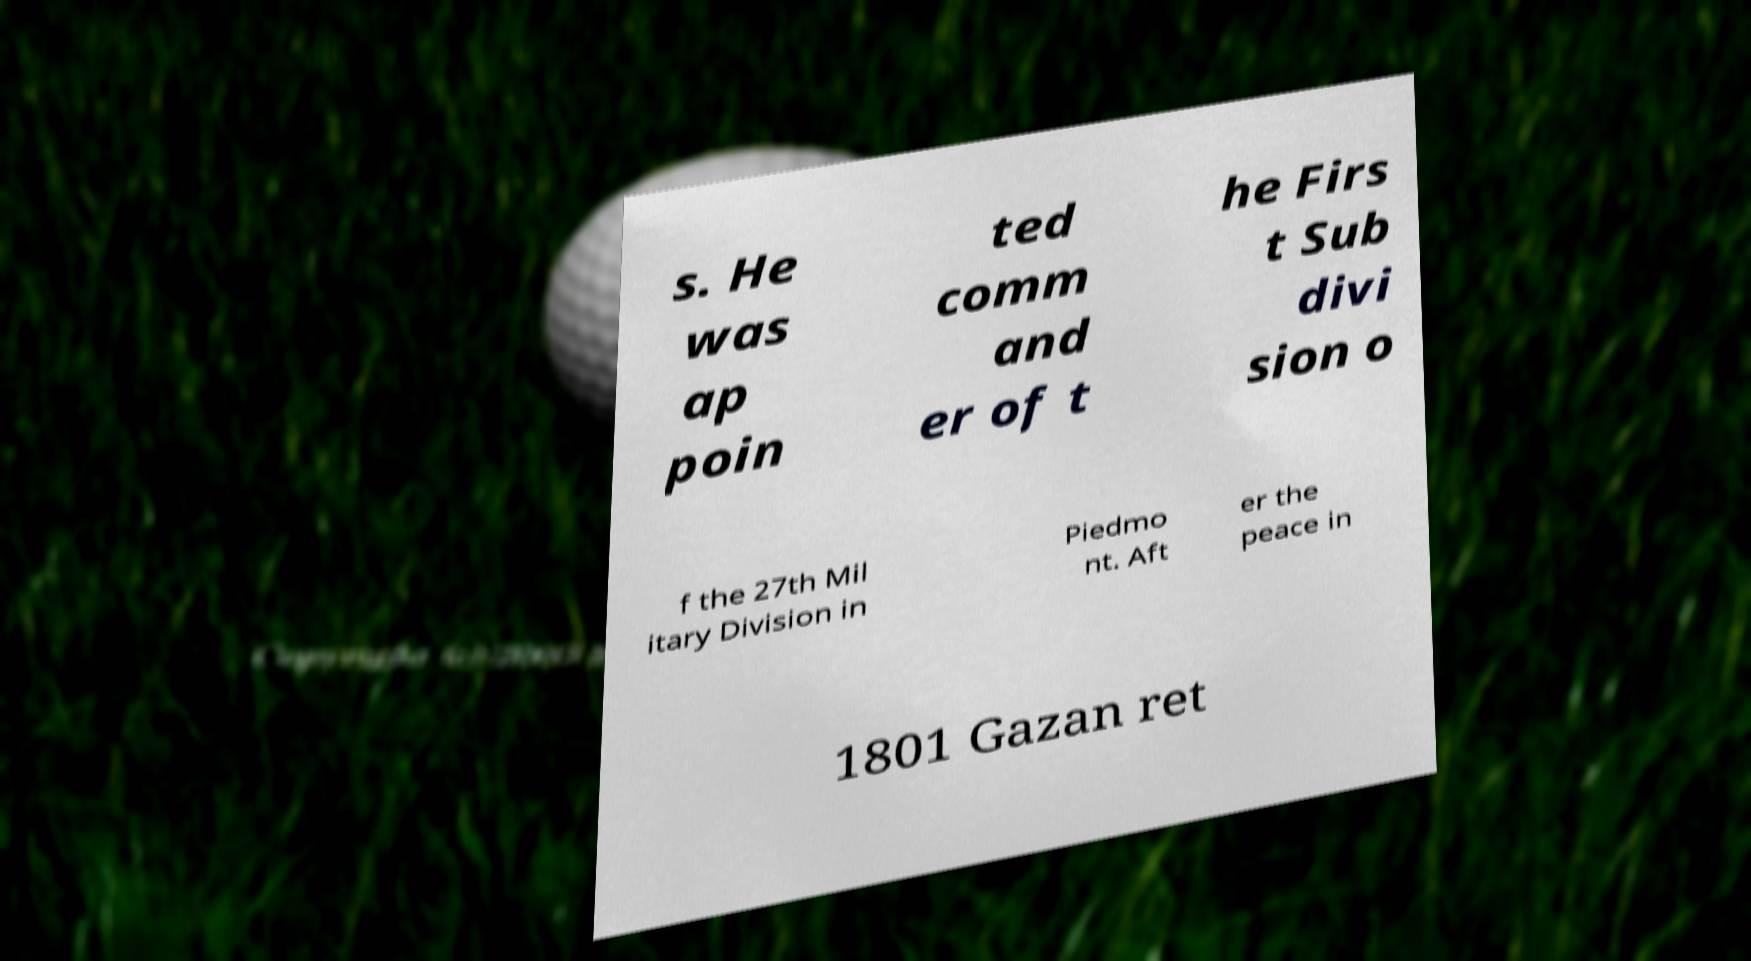There's text embedded in this image that I need extracted. Can you transcribe it verbatim? s. He was ap poin ted comm and er of t he Firs t Sub divi sion o f the 27th Mil itary Division in Piedmo nt. Aft er the peace in 1801 Gazan ret 